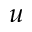<formula> <loc_0><loc_0><loc_500><loc_500>u</formula> 